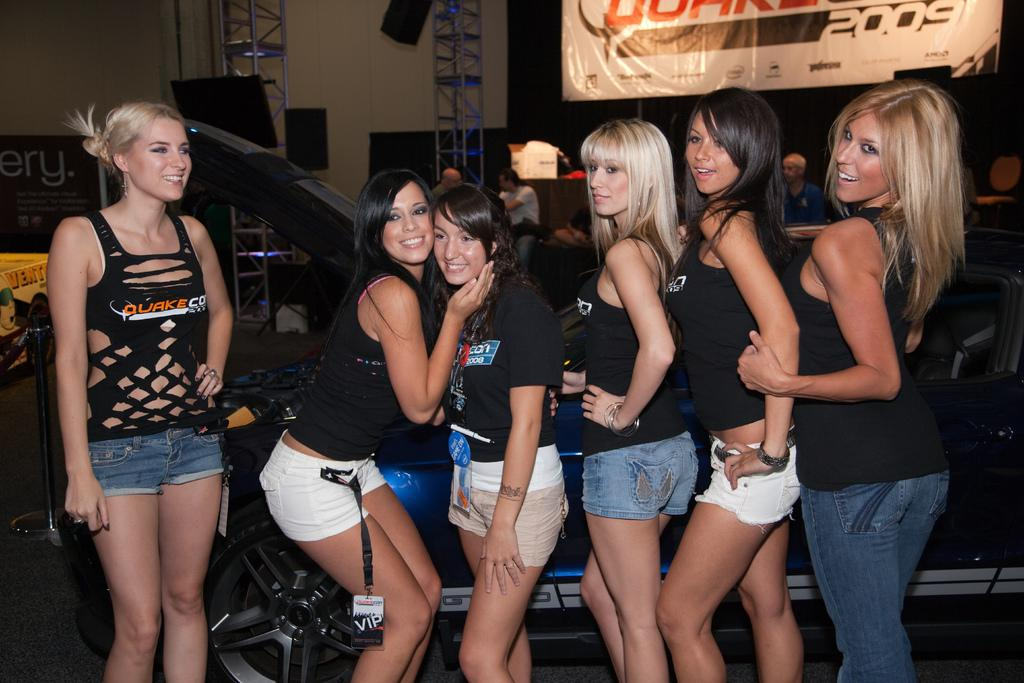What is the main subject in the foreground of the picture? There are women standing in the foreground of the picture. What are the women standing beside? The women are beside a car. What can be seen in the background of the picture? There is a banner, iron frames, people, and other objects in the background of the picture. Can you describe the stand on the left side of the picture? There is a stand on the left side of the picture. What type of ray is visible in the picture? There is no ray present in the picture. What grade is the car in the picture? The grade of the car cannot be determined from the picture. 